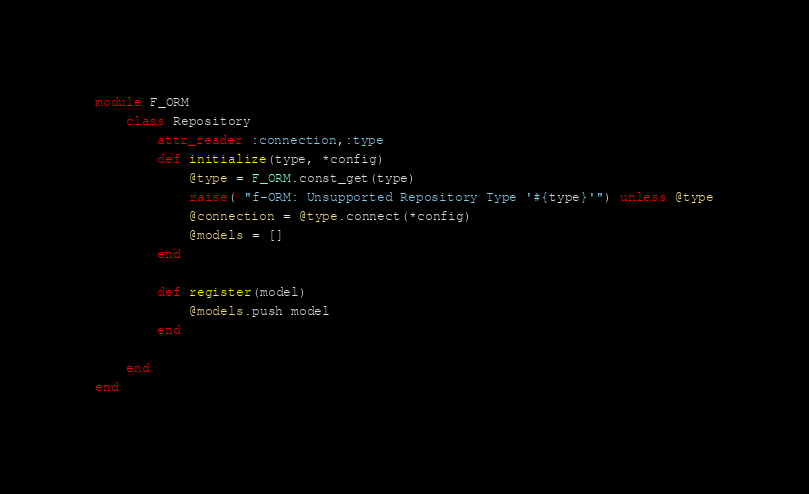Convert code to text. <code><loc_0><loc_0><loc_500><loc_500><_Ruby_>module F_ORM
	class Repository
		attr_reader :connection,:type
		def initialize(type, *config)
			@type = F_ORM.const_get(type)
			raise( "f-ORM: Unsupported Repository Type '#{type}'") unless @type
			@connection = @type.connect(*config)
			@models = []
		end

		def register(model)
			@models.push model
		end

	end
end</code> 